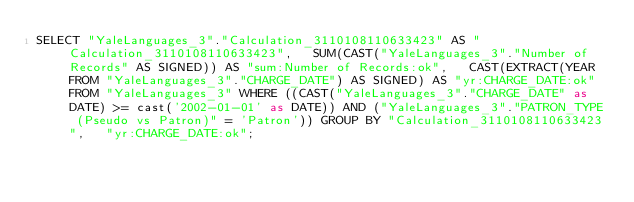<code> <loc_0><loc_0><loc_500><loc_500><_SQL_>SELECT "YaleLanguages_3"."Calculation_3110108110633423" AS "Calculation_3110108110633423",   SUM(CAST("YaleLanguages_3"."Number of Records" AS SIGNED)) AS "sum:Number of Records:ok",   CAST(EXTRACT(YEAR FROM "YaleLanguages_3"."CHARGE_DATE") AS SIGNED) AS "yr:CHARGE_DATE:ok" FROM "YaleLanguages_3" WHERE ((CAST("YaleLanguages_3"."CHARGE_DATE" as DATE) >= cast('2002-01-01' as DATE)) AND ("YaleLanguages_3"."PATRON_TYPE (Pseudo vs Patron)" = 'Patron')) GROUP BY "Calculation_3110108110633423",   "yr:CHARGE_DATE:ok";
</code> 